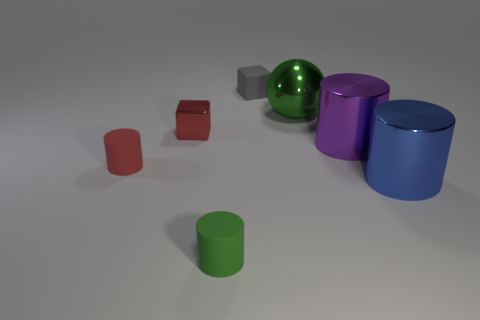What number of metal blocks are the same size as the ball?
Provide a succinct answer. 0. Are there fewer small green rubber cylinders that are on the left side of the small metal thing than red cubes?
Your response must be concise. Yes. What number of red metal objects are in front of the large blue cylinder?
Provide a short and direct response. 0. There is a metal cylinder behind the thing that is on the left side of the small cube that is to the left of the small gray matte thing; how big is it?
Give a very brief answer. Large. There is a small metal object; does it have the same shape as the green thing that is in front of the big green object?
Offer a very short reply. No. What is the size of the red object that is made of the same material as the green cylinder?
Your answer should be very brief. Small. Is there anything else that is the same color as the tiny metallic thing?
Keep it short and to the point. Yes. What is the green object that is right of the tiny cube that is to the right of the cube that is in front of the big sphere made of?
Offer a terse response. Metal. How many matte things are either small red spheres or blue cylinders?
Your answer should be very brief. 0. Is the small metal object the same color as the large metal ball?
Your answer should be compact. No. 